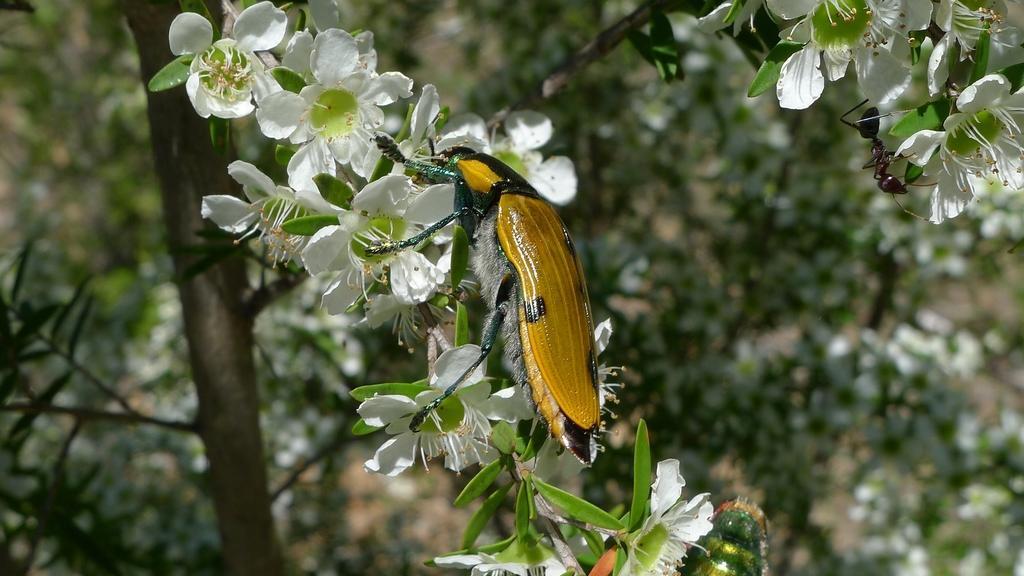Please provide a concise description of this image. In this picture we can see flowers and leaves in the front, there is an insect on the flowers, on the right side we can see an ant, in the background there are some plants, we can see a blurry background. 